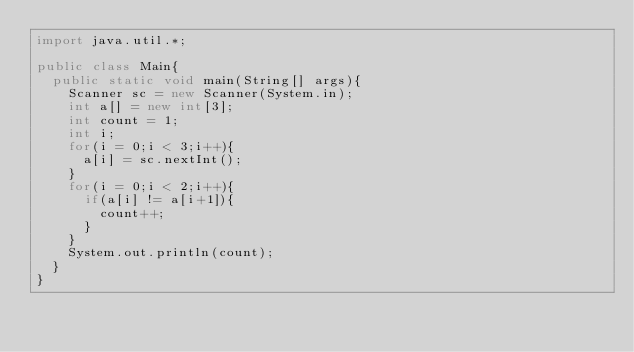<code> <loc_0><loc_0><loc_500><loc_500><_Java_>import java.util.*;

public class Main{
  public static void main(String[] args){
    Scanner sc = new Scanner(System.in);
    int a[] = new int[3];
    int count = 1;
    int i;
    for(i = 0;i < 3;i++){
      a[i] = sc.nextInt();
    }
    for(i = 0;i < 2;i++){
      if(a[i] != a[i+1]){
        count++;
      }
    }
    System.out.println(count);
  }
}
</code> 